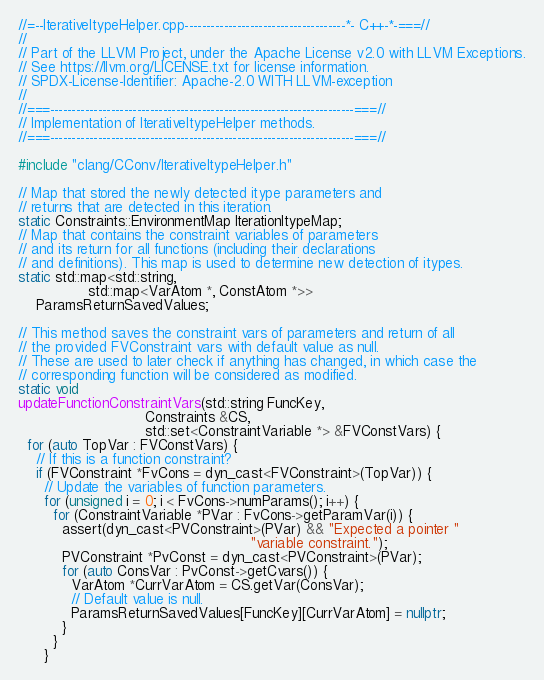<code> <loc_0><loc_0><loc_500><loc_500><_C++_>//=--IterativeItypeHelper.cpp-------------------------------------*- C++-*-===//
//
// Part of the LLVM Project, under the Apache License v2.0 with LLVM Exceptions.
// See https://llvm.org/LICENSE.txt for license information.
// SPDX-License-Identifier: Apache-2.0 WITH LLVM-exception
//
//===----------------------------------------------------------------------===//
// Implementation of IterativeItypeHelper methods.
//===----------------------------------------------------------------------===//

#include "clang/CConv/IterativeItypeHelper.h"

// Map that stored the newly detected itype parameters and
// returns that are detected in this iteration.
static Constraints::EnvironmentMap IterationItypeMap;
// Map that contains the constraint variables of parameters
// and its return for all functions (including their declarations
// and definitions). This map is used to determine new detection of itypes.
static std::map<std::string,
                std::map<VarAtom *, ConstAtom *>>
    ParamsReturnSavedValues;

// This method saves the constraint vars of parameters and return of all
// the provided FVConstraint vars with default value as null.
// These are used to later check if anything has changed, in which case the
// corresponding function will be considered as modified.
static void
updateFunctionConstraintVars(std::string FuncKey,
                             Constraints &CS,
                             std::set<ConstraintVariable *> &FVConstVars) {
  for (auto TopVar : FVConstVars) {
    // If this is a function constraint?
    if (FVConstraint *FvCons = dyn_cast<FVConstraint>(TopVar)) {
      // Update the variables of function parameters.
      for (unsigned i = 0; i < FvCons->numParams(); i++) {
        for (ConstraintVariable *PVar : FvCons->getParamVar(i)) {
          assert(dyn_cast<PVConstraint>(PVar) && "Expected a pointer "
                                                     "variable constraint.");
          PVConstraint *PvConst = dyn_cast<PVConstraint>(PVar);
          for (auto ConsVar : PvConst->getCvars()) {
            VarAtom *CurrVarAtom = CS.getVar(ConsVar);
            // Default value is null.
            ParamsReturnSavedValues[FuncKey][CurrVarAtom] = nullptr;
          }
        }
      }</code> 